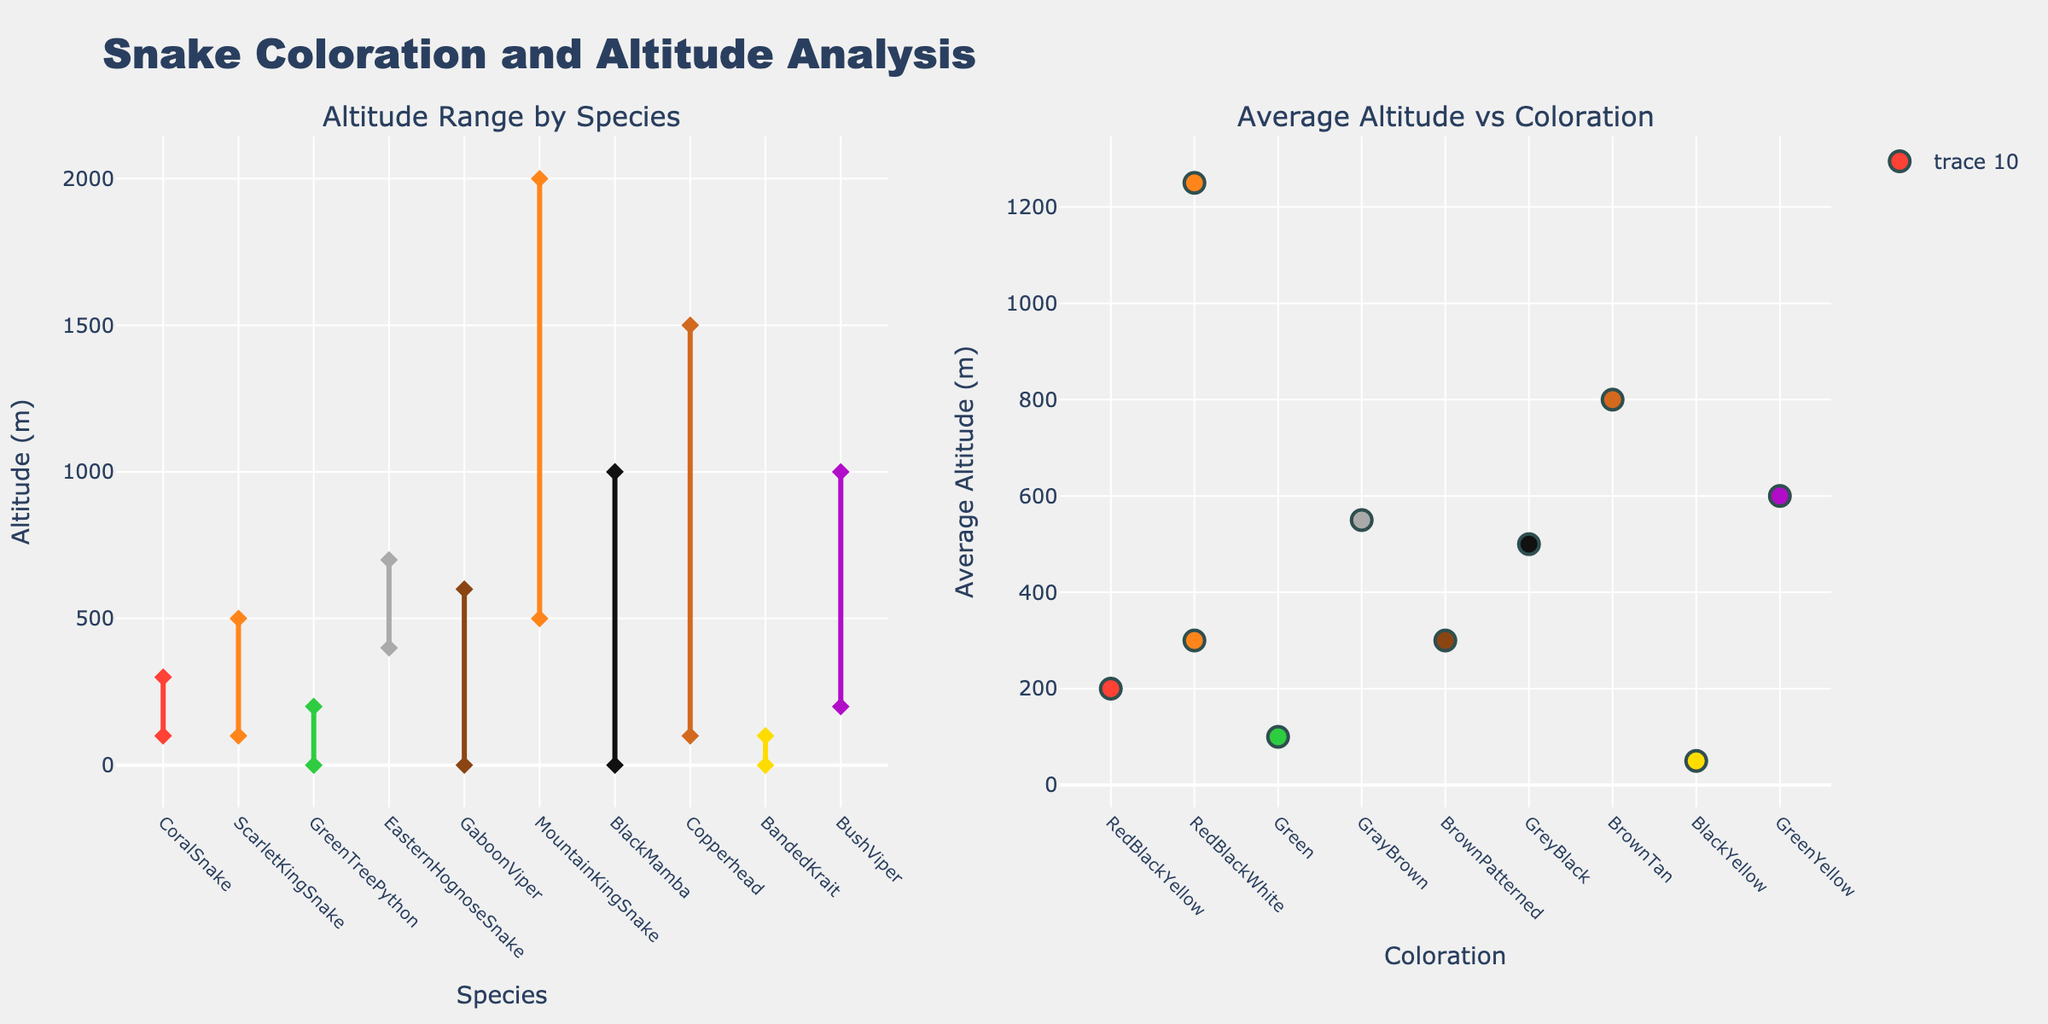How many different colorations are represented in the figure? Count the unique coloration categories displayed in the scatter plot on the right. There are 9 distinct colorations indicated by different colors in the plot.
Answer: 9 What is the average altitude range for the Black Mamba? Locate the Black Mamba on both subplots. Its altitude range is 0-1000 meters. The average is (0 + 1000) / 2.
Answer: 500 Which species has the highest maximum altitude range? Observe the left plot and identify the species with the highest point on the y-axis. The highest maximum altitude range is for the Mountain King Snake at 2000 meters.
Answer: Mountain King Snake What is the coloration of the species found at the lowest average altitude? On the right subplot, find the lowest point on the y-axis, which corresponds to the coloration of the species. Banded Kraits have the lowest average altitude at approximately 50 meters and are BlackYellow.
Answer: BlackYellow Which two species have a shared coloration and what is their coloration? From the right subplot, observe that the Scarlet King Snake and the Mountain King Snake share the 'RedBlackWhite' coloration.
Answer: Scarlet King Snake, Mountain King Snake; RedBlackWhite Compare the average altitude of the Coral Snake and the Copperhead. Which one is higher? In the right plot, locate both species' average altitudes and compare. The Copperhead's average altitude is 800 meters whereas the Coral Snake's is 200 meters.
Answer: Copperhead Determine the color associated with the highest average altitude. On the right subplot, find the data point at the top of the y-axis, representing the highest average altitude. The color for this point is BrownTan, corresponding to the Copperhead.
Answer: BrownTan What is the total altitude range (difference between highest and lowest point) for the Green Tree Python? In the left plot, find the altitude points for the Green Tree Python. The range is 0-200 meters. Subtract the lowest altitude from the highest. The difference is 200 - 0.
Answer: 200 Which species have average altitudes within the range of 100-200 meters? From the right subplot, identify the species whose average altitude values lie between 100 and 200 on the y-axis. The Coral Snake and the Green Tree Python's average altitudes fall within this range.
Answer: Coral Snake, Green Tree Python 